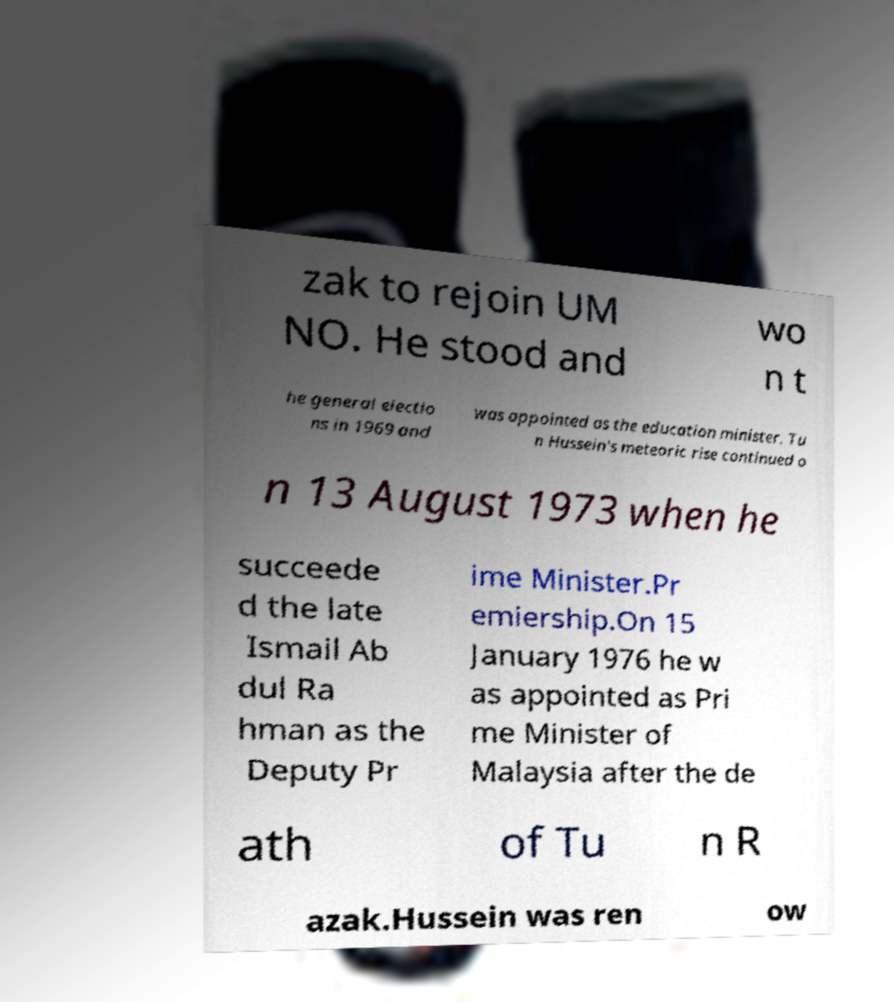Please read and relay the text visible in this image. What does it say? zak to rejoin UM NO. He stood and wo n t he general electio ns in 1969 and was appointed as the education minister. Tu n Hussein's meteoric rise continued o n 13 August 1973 when he succeede d the late Ismail Ab dul Ra hman as the Deputy Pr ime Minister.Pr emiership.On 15 January 1976 he w as appointed as Pri me Minister of Malaysia after the de ath of Tu n R azak.Hussein was ren ow 